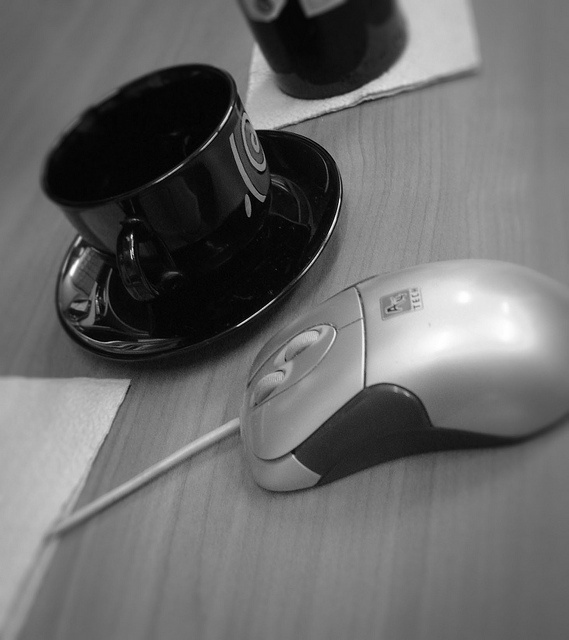Describe the objects in this image and their specific colors. I can see dining table in gray, black, and lightgray tones, mouse in gray, darkgray, lightgray, and black tones, cup in gray, black, and lightgray tones, and cup in gray, black, darkgray, and lightgray tones in this image. 